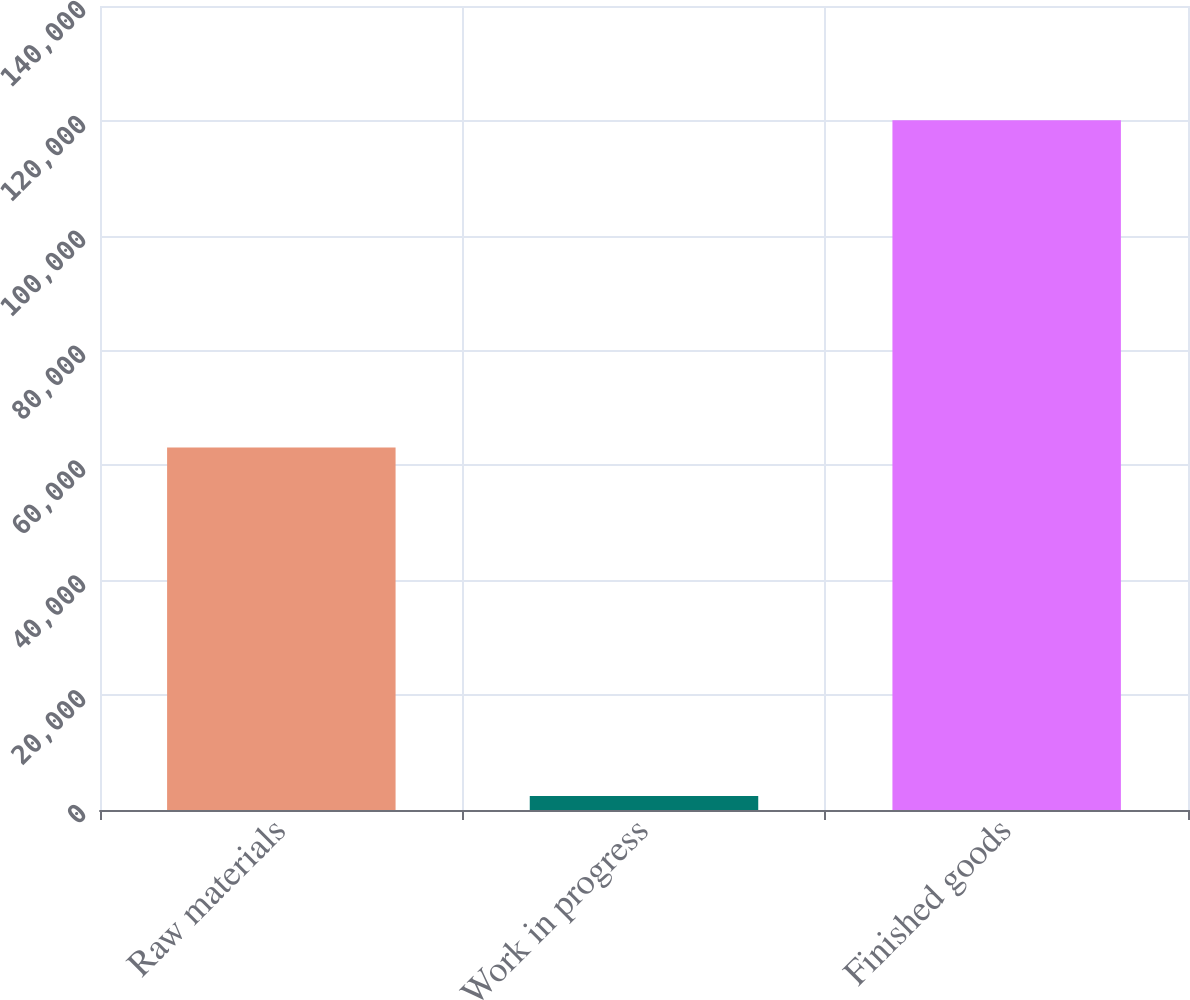Convert chart to OTSL. <chart><loc_0><loc_0><loc_500><loc_500><bar_chart><fcel>Raw materials<fcel>Work in progress<fcel>Finished goods<nl><fcel>63120<fcel>2427<fcel>120095<nl></chart> 